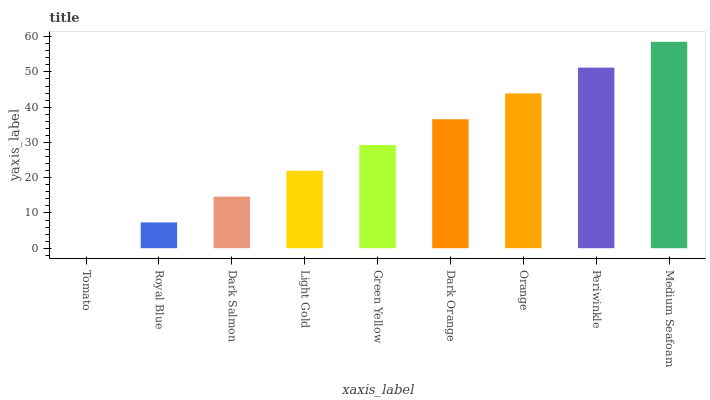Is Royal Blue the minimum?
Answer yes or no. No. Is Royal Blue the maximum?
Answer yes or no. No. Is Royal Blue greater than Tomato?
Answer yes or no. Yes. Is Tomato less than Royal Blue?
Answer yes or no. Yes. Is Tomato greater than Royal Blue?
Answer yes or no. No. Is Royal Blue less than Tomato?
Answer yes or no. No. Is Green Yellow the high median?
Answer yes or no. Yes. Is Green Yellow the low median?
Answer yes or no. Yes. Is Periwinkle the high median?
Answer yes or no. No. Is Light Gold the low median?
Answer yes or no. No. 